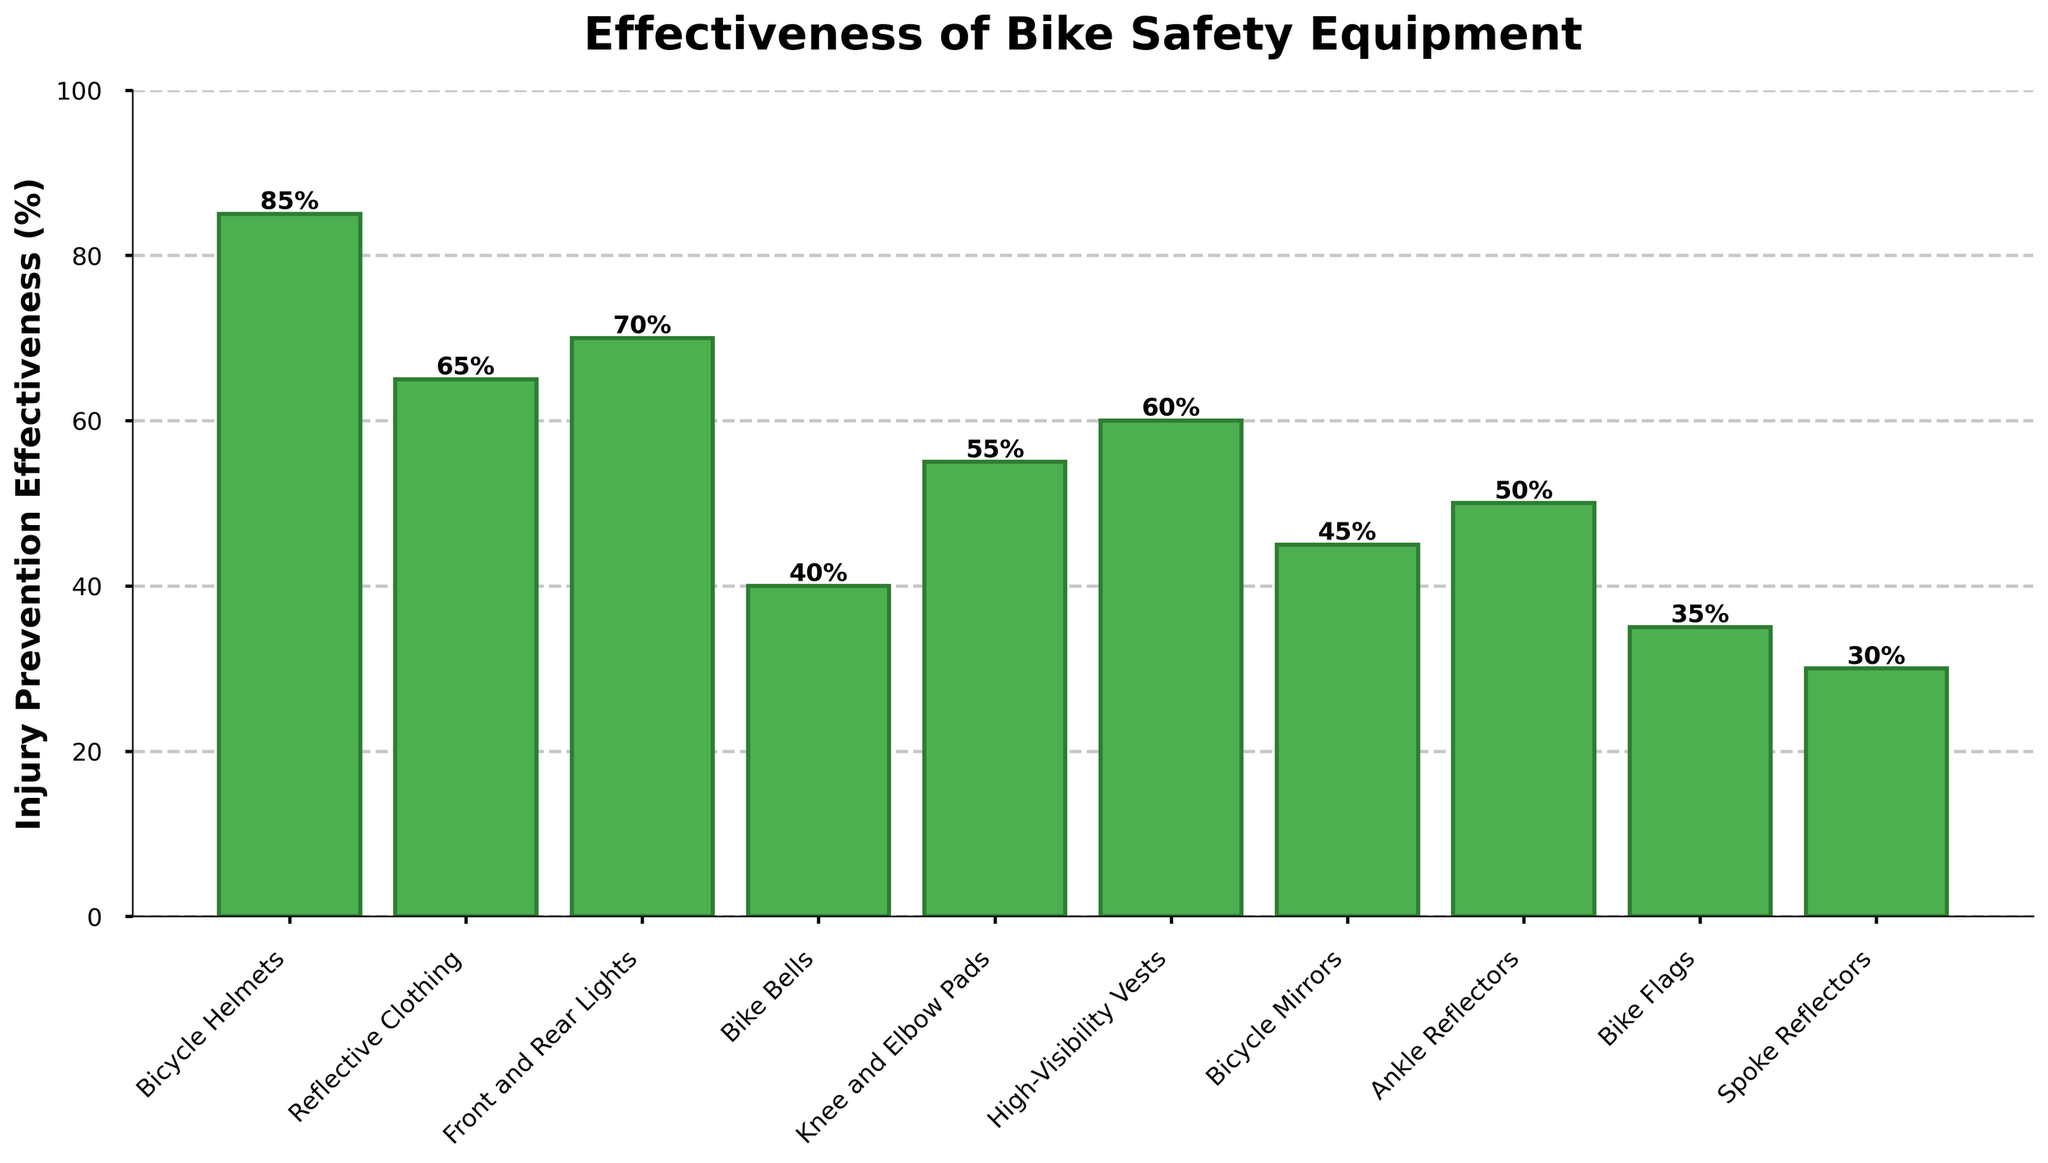Which type of bike safety equipment is the most effective in preventing injuries? The highest value on the y-axis corresponds to the Bicycle Helmets bar with 85% effectiveness in injury prevention.
Answer: Bicycle Helmets Which equipment type has the lowest injury prevention effectiveness and what is its percentage? The lowest bar corresponds to Spoke Reflectors, with an effectiveness of 30%.
Answer: Spoke Reflectors with 30% How much more effective are Bicycle Helmets compared to Bike Bells? Bicycle Helmets have an effectiveness of 85%, while Bike Bells have 40%. The difference is 85% - 40% = 45%.
Answer: 45% Are Front and Rear Lights more effective than High-Visibility Vests? Front and Rear Lights have an effectiveness of 70%, while High-Visibility Vests have 60%. 70% > 60%, so yes.
Answer: Yes What is the average injury prevention effectiveness of all the equipment types shown? Sum the effectiveness values and divide by the number of equipment types. (85 + 65 + 70 + 40 + 55 + 60 + 45 + 50 + 35 + 30) / 10 = 535 / 10 = 53.5%
Answer: 53.5% Which equipment types have an effectiveness percentage equal to or higher than 50%? Identify bars with heights ≥ 50%: Bicycle Helmets (85%), Reflective Clothing (65%), Front and Rear Lights (70%), Knee and Elbow Pads (55%), High-Visibility Vests (60%), Ankle Reflectors (50%).
Answer: Bicycle Helmets, Reflective Clothing, Front and Rear Lights, Knee and Elbow Pads, High-Visibility Vests, Ankle Reflectors Compare the effectiveness of Reflective Clothing and Bicycle Mirrors. How much more effective are Reflective Clothing? Reflective Clothing has 65% effectiveness, and Bicycle Mirrors have 45%. The difference is 65% - 45% = 20%.
Answer: 20% Which equipment types fall between 40% to 60% effectiveness? Identify bars with heights in the range of 40% to 60%: Bike Bells (40%), Knee and Elbow Pads (55%), High-Visibility Vests (60%), Bicycle Mirrors (45%), Ankle Reflectors (50%).
Answer: Bike Bells, Knee and Elbow Pads, High-Visibility Vests, Bicycle Mirrors, Ankle Reflectors Order the top three most effective equipment types in descending order of their effectiveness percentages. Identify and sort: Bicycle Helmets (85%), Front and Rear Lights (70%), Reflective Clothing (65%).
Answer: Bicycle Helmets, Front and Rear Lights, Reflective Clothing What is the combined effectiveness of Bicycle Helmets, Knee and Elbow Pads, and Bike Flags? Sum the effectiveness percentages: 85% (Bicycle Helmets) + 55% (Knee and Elbow Pads) + 35% (Bike Flags) = 175%.
Answer: 175% 